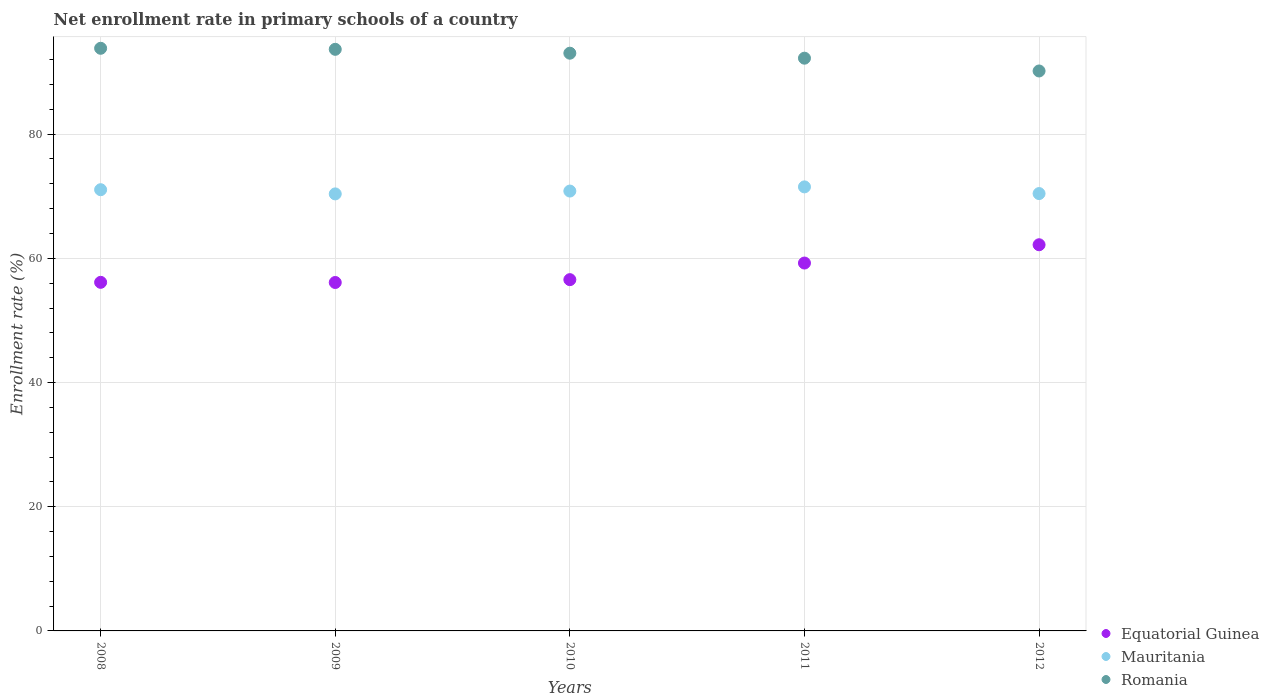How many different coloured dotlines are there?
Provide a short and direct response. 3. Is the number of dotlines equal to the number of legend labels?
Offer a terse response. Yes. What is the enrollment rate in primary schools in Mauritania in 2009?
Your response must be concise. 70.38. Across all years, what is the maximum enrollment rate in primary schools in Romania?
Ensure brevity in your answer.  93.83. Across all years, what is the minimum enrollment rate in primary schools in Mauritania?
Offer a very short reply. 70.38. In which year was the enrollment rate in primary schools in Romania minimum?
Provide a succinct answer. 2012. What is the total enrollment rate in primary schools in Mauritania in the graph?
Your answer should be compact. 354.21. What is the difference between the enrollment rate in primary schools in Mauritania in 2010 and that in 2012?
Ensure brevity in your answer.  0.4. What is the difference between the enrollment rate in primary schools in Equatorial Guinea in 2008 and the enrollment rate in primary schools in Romania in 2012?
Offer a very short reply. -34.04. What is the average enrollment rate in primary schools in Romania per year?
Offer a very short reply. 92.59. In the year 2012, what is the difference between the enrollment rate in primary schools in Mauritania and enrollment rate in primary schools in Romania?
Give a very brief answer. -19.74. What is the ratio of the enrollment rate in primary schools in Romania in 2009 to that in 2012?
Your answer should be very brief. 1.04. What is the difference between the highest and the second highest enrollment rate in primary schools in Romania?
Give a very brief answer. 0.17. What is the difference between the highest and the lowest enrollment rate in primary schools in Equatorial Guinea?
Keep it short and to the point. 6.08. Is the sum of the enrollment rate in primary schools in Mauritania in 2008 and 2010 greater than the maximum enrollment rate in primary schools in Equatorial Guinea across all years?
Offer a very short reply. Yes. How many dotlines are there?
Provide a succinct answer. 3. Does the graph contain grids?
Provide a succinct answer. Yes. What is the title of the graph?
Provide a short and direct response. Net enrollment rate in primary schools of a country. What is the label or title of the Y-axis?
Provide a short and direct response. Enrollment rate (%). What is the Enrollment rate (%) in Equatorial Guinea in 2008?
Provide a short and direct response. 56.14. What is the Enrollment rate (%) in Mauritania in 2008?
Make the answer very short. 71.05. What is the Enrollment rate (%) in Romania in 2008?
Offer a very short reply. 93.83. What is the Enrollment rate (%) of Equatorial Guinea in 2009?
Offer a very short reply. 56.11. What is the Enrollment rate (%) in Mauritania in 2009?
Offer a terse response. 70.38. What is the Enrollment rate (%) of Romania in 2009?
Keep it short and to the point. 93.66. What is the Enrollment rate (%) of Equatorial Guinea in 2010?
Give a very brief answer. 56.57. What is the Enrollment rate (%) of Mauritania in 2010?
Provide a short and direct response. 70.84. What is the Enrollment rate (%) of Romania in 2010?
Your answer should be compact. 93.04. What is the Enrollment rate (%) in Equatorial Guinea in 2011?
Offer a very short reply. 59.24. What is the Enrollment rate (%) in Mauritania in 2011?
Your answer should be very brief. 71.51. What is the Enrollment rate (%) in Romania in 2011?
Your answer should be compact. 92.23. What is the Enrollment rate (%) in Equatorial Guinea in 2012?
Make the answer very short. 62.19. What is the Enrollment rate (%) of Mauritania in 2012?
Your answer should be compact. 70.43. What is the Enrollment rate (%) in Romania in 2012?
Your answer should be compact. 90.17. Across all years, what is the maximum Enrollment rate (%) in Equatorial Guinea?
Offer a very short reply. 62.19. Across all years, what is the maximum Enrollment rate (%) of Mauritania?
Offer a very short reply. 71.51. Across all years, what is the maximum Enrollment rate (%) of Romania?
Provide a succinct answer. 93.83. Across all years, what is the minimum Enrollment rate (%) in Equatorial Guinea?
Offer a terse response. 56.11. Across all years, what is the minimum Enrollment rate (%) of Mauritania?
Your response must be concise. 70.38. Across all years, what is the minimum Enrollment rate (%) of Romania?
Offer a terse response. 90.17. What is the total Enrollment rate (%) in Equatorial Guinea in the graph?
Your response must be concise. 290.25. What is the total Enrollment rate (%) in Mauritania in the graph?
Your answer should be very brief. 354.21. What is the total Enrollment rate (%) of Romania in the graph?
Ensure brevity in your answer.  462.94. What is the difference between the Enrollment rate (%) in Equatorial Guinea in 2008 and that in 2009?
Ensure brevity in your answer.  0.03. What is the difference between the Enrollment rate (%) in Mauritania in 2008 and that in 2009?
Your answer should be very brief. 0.67. What is the difference between the Enrollment rate (%) of Romania in 2008 and that in 2009?
Ensure brevity in your answer.  0.17. What is the difference between the Enrollment rate (%) in Equatorial Guinea in 2008 and that in 2010?
Offer a terse response. -0.43. What is the difference between the Enrollment rate (%) of Mauritania in 2008 and that in 2010?
Provide a short and direct response. 0.22. What is the difference between the Enrollment rate (%) in Romania in 2008 and that in 2010?
Provide a succinct answer. 0.79. What is the difference between the Enrollment rate (%) of Equatorial Guinea in 2008 and that in 2011?
Give a very brief answer. -3.11. What is the difference between the Enrollment rate (%) in Mauritania in 2008 and that in 2011?
Your answer should be very brief. -0.46. What is the difference between the Enrollment rate (%) of Romania in 2008 and that in 2011?
Your response must be concise. 1.59. What is the difference between the Enrollment rate (%) of Equatorial Guinea in 2008 and that in 2012?
Provide a short and direct response. -6.05. What is the difference between the Enrollment rate (%) of Mauritania in 2008 and that in 2012?
Ensure brevity in your answer.  0.62. What is the difference between the Enrollment rate (%) in Romania in 2008 and that in 2012?
Make the answer very short. 3.65. What is the difference between the Enrollment rate (%) of Equatorial Guinea in 2009 and that in 2010?
Ensure brevity in your answer.  -0.46. What is the difference between the Enrollment rate (%) in Mauritania in 2009 and that in 2010?
Give a very brief answer. -0.46. What is the difference between the Enrollment rate (%) of Romania in 2009 and that in 2010?
Keep it short and to the point. 0.62. What is the difference between the Enrollment rate (%) in Equatorial Guinea in 2009 and that in 2011?
Provide a succinct answer. -3.13. What is the difference between the Enrollment rate (%) of Mauritania in 2009 and that in 2011?
Ensure brevity in your answer.  -1.13. What is the difference between the Enrollment rate (%) of Romania in 2009 and that in 2011?
Keep it short and to the point. 1.43. What is the difference between the Enrollment rate (%) of Equatorial Guinea in 2009 and that in 2012?
Offer a terse response. -6.08. What is the difference between the Enrollment rate (%) of Mauritania in 2009 and that in 2012?
Make the answer very short. -0.05. What is the difference between the Enrollment rate (%) of Romania in 2009 and that in 2012?
Provide a succinct answer. 3.49. What is the difference between the Enrollment rate (%) in Equatorial Guinea in 2010 and that in 2011?
Your answer should be compact. -2.67. What is the difference between the Enrollment rate (%) in Mauritania in 2010 and that in 2011?
Offer a terse response. -0.67. What is the difference between the Enrollment rate (%) in Romania in 2010 and that in 2011?
Your response must be concise. 0.8. What is the difference between the Enrollment rate (%) in Equatorial Guinea in 2010 and that in 2012?
Your answer should be compact. -5.62. What is the difference between the Enrollment rate (%) in Mauritania in 2010 and that in 2012?
Provide a succinct answer. 0.4. What is the difference between the Enrollment rate (%) of Romania in 2010 and that in 2012?
Provide a succinct answer. 2.86. What is the difference between the Enrollment rate (%) in Equatorial Guinea in 2011 and that in 2012?
Keep it short and to the point. -2.95. What is the difference between the Enrollment rate (%) of Mauritania in 2011 and that in 2012?
Offer a very short reply. 1.08. What is the difference between the Enrollment rate (%) of Romania in 2011 and that in 2012?
Keep it short and to the point. 2.06. What is the difference between the Enrollment rate (%) in Equatorial Guinea in 2008 and the Enrollment rate (%) in Mauritania in 2009?
Ensure brevity in your answer.  -14.24. What is the difference between the Enrollment rate (%) in Equatorial Guinea in 2008 and the Enrollment rate (%) in Romania in 2009?
Give a very brief answer. -37.52. What is the difference between the Enrollment rate (%) of Mauritania in 2008 and the Enrollment rate (%) of Romania in 2009?
Offer a very short reply. -22.61. What is the difference between the Enrollment rate (%) in Equatorial Guinea in 2008 and the Enrollment rate (%) in Mauritania in 2010?
Your response must be concise. -14.7. What is the difference between the Enrollment rate (%) in Equatorial Guinea in 2008 and the Enrollment rate (%) in Romania in 2010?
Keep it short and to the point. -36.9. What is the difference between the Enrollment rate (%) in Mauritania in 2008 and the Enrollment rate (%) in Romania in 2010?
Ensure brevity in your answer.  -21.98. What is the difference between the Enrollment rate (%) in Equatorial Guinea in 2008 and the Enrollment rate (%) in Mauritania in 2011?
Offer a very short reply. -15.37. What is the difference between the Enrollment rate (%) in Equatorial Guinea in 2008 and the Enrollment rate (%) in Romania in 2011?
Your response must be concise. -36.1. What is the difference between the Enrollment rate (%) in Mauritania in 2008 and the Enrollment rate (%) in Romania in 2011?
Offer a terse response. -21.18. What is the difference between the Enrollment rate (%) of Equatorial Guinea in 2008 and the Enrollment rate (%) of Mauritania in 2012?
Your answer should be compact. -14.29. What is the difference between the Enrollment rate (%) in Equatorial Guinea in 2008 and the Enrollment rate (%) in Romania in 2012?
Keep it short and to the point. -34.04. What is the difference between the Enrollment rate (%) in Mauritania in 2008 and the Enrollment rate (%) in Romania in 2012?
Ensure brevity in your answer.  -19.12. What is the difference between the Enrollment rate (%) of Equatorial Guinea in 2009 and the Enrollment rate (%) of Mauritania in 2010?
Your answer should be compact. -14.72. What is the difference between the Enrollment rate (%) of Equatorial Guinea in 2009 and the Enrollment rate (%) of Romania in 2010?
Keep it short and to the point. -36.93. What is the difference between the Enrollment rate (%) in Mauritania in 2009 and the Enrollment rate (%) in Romania in 2010?
Provide a short and direct response. -22.66. What is the difference between the Enrollment rate (%) of Equatorial Guinea in 2009 and the Enrollment rate (%) of Mauritania in 2011?
Ensure brevity in your answer.  -15.4. What is the difference between the Enrollment rate (%) in Equatorial Guinea in 2009 and the Enrollment rate (%) in Romania in 2011?
Your answer should be compact. -36.12. What is the difference between the Enrollment rate (%) in Mauritania in 2009 and the Enrollment rate (%) in Romania in 2011?
Give a very brief answer. -21.86. What is the difference between the Enrollment rate (%) in Equatorial Guinea in 2009 and the Enrollment rate (%) in Mauritania in 2012?
Your answer should be compact. -14.32. What is the difference between the Enrollment rate (%) in Equatorial Guinea in 2009 and the Enrollment rate (%) in Romania in 2012?
Give a very brief answer. -34.06. What is the difference between the Enrollment rate (%) in Mauritania in 2009 and the Enrollment rate (%) in Romania in 2012?
Offer a terse response. -19.8. What is the difference between the Enrollment rate (%) of Equatorial Guinea in 2010 and the Enrollment rate (%) of Mauritania in 2011?
Provide a short and direct response. -14.94. What is the difference between the Enrollment rate (%) in Equatorial Guinea in 2010 and the Enrollment rate (%) in Romania in 2011?
Offer a very short reply. -35.66. What is the difference between the Enrollment rate (%) of Mauritania in 2010 and the Enrollment rate (%) of Romania in 2011?
Give a very brief answer. -21.4. What is the difference between the Enrollment rate (%) in Equatorial Guinea in 2010 and the Enrollment rate (%) in Mauritania in 2012?
Offer a terse response. -13.86. What is the difference between the Enrollment rate (%) of Equatorial Guinea in 2010 and the Enrollment rate (%) of Romania in 2012?
Offer a terse response. -33.61. What is the difference between the Enrollment rate (%) of Mauritania in 2010 and the Enrollment rate (%) of Romania in 2012?
Offer a very short reply. -19.34. What is the difference between the Enrollment rate (%) of Equatorial Guinea in 2011 and the Enrollment rate (%) of Mauritania in 2012?
Provide a short and direct response. -11.19. What is the difference between the Enrollment rate (%) in Equatorial Guinea in 2011 and the Enrollment rate (%) in Romania in 2012?
Your response must be concise. -30.93. What is the difference between the Enrollment rate (%) in Mauritania in 2011 and the Enrollment rate (%) in Romania in 2012?
Your answer should be very brief. -18.67. What is the average Enrollment rate (%) in Equatorial Guinea per year?
Provide a short and direct response. 58.05. What is the average Enrollment rate (%) in Mauritania per year?
Your answer should be compact. 70.84. What is the average Enrollment rate (%) in Romania per year?
Provide a succinct answer. 92.59. In the year 2008, what is the difference between the Enrollment rate (%) of Equatorial Guinea and Enrollment rate (%) of Mauritania?
Your response must be concise. -14.92. In the year 2008, what is the difference between the Enrollment rate (%) of Equatorial Guinea and Enrollment rate (%) of Romania?
Your answer should be very brief. -37.69. In the year 2008, what is the difference between the Enrollment rate (%) of Mauritania and Enrollment rate (%) of Romania?
Offer a terse response. -22.77. In the year 2009, what is the difference between the Enrollment rate (%) in Equatorial Guinea and Enrollment rate (%) in Mauritania?
Offer a very short reply. -14.27. In the year 2009, what is the difference between the Enrollment rate (%) in Equatorial Guinea and Enrollment rate (%) in Romania?
Offer a very short reply. -37.55. In the year 2009, what is the difference between the Enrollment rate (%) of Mauritania and Enrollment rate (%) of Romania?
Offer a very short reply. -23.28. In the year 2010, what is the difference between the Enrollment rate (%) in Equatorial Guinea and Enrollment rate (%) in Mauritania?
Make the answer very short. -14.27. In the year 2010, what is the difference between the Enrollment rate (%) of Equatorial Guinea and Enrollment rate (%) of Romania?
Make the answer very short. -36.47. In the year 2010, what is the difference between the Enrollment rate (%) of Mauritania and Enrollment rate (%) of Romania?
Give a very brief answer. -22.2. In the year 2011, what is the difference between the Enrollment rate (%) in Equatorial Guinea and Enrollment rate (%) in Mauritania?
Make the answer very short. -12.27. In the year 2011, what is the difference between the Enrollment rate (%) in Equatorial Guinea and Enrollment rate (%) in Romania?
Give a very brief answer. -32.99. In the year 2011, what is the difference between the Enrollment rate (%) in Mauritania and Enrollment rate (%) in Romania?
Your answer should be compact. -20.72. In the year 2012, what is the difference between the Enrollment rate (%) in Equatorial Guinea and Enrollment rate (%) in Mauritania?
Your answer should be compact. -8.24. In the year 2012, what is the difference between the Enrollment rate (%) in Equatorial Guinea and Enrollment rate (%) in Romania?
Provide a succinct answer. -27.99. In the year 2012, what is the difference between the Enrollment rate (%) in Mauritania and Enrollment rate (%) in Romania?
Keep it short and to the point. -19.74. What is the ratio of the Enrollment rate (%) in Equatorial Guinea in 2008 to that in 2009?
Ensure brevity in your answer.  1. What is the ratio of the Enrollment rate (%) in Mauritania in 2008 to that in 2009?
Your answer should be very brief. 1.01. What is the ratio of the Enrollment rate (%) in Equatorial Guinea in 2008 to that in 2010?
Your answer should be very brief. 0.99. What is the ratio of the Enrollment rate (%) in Romania in 2008 to that in 2010?
Provide a short and direct response. 1.01. What is the ratio of the Enrollment rate (%) in Equatorial Guinea in 2008 to that in 2011?
Provide a short and direct response. 0.95. What is the ratio of the Enrollment rate (%) in Mauritania in 2008 to that in 2011?
Your response must be concise. 0.99. What is the ratio of the Enrollment rate (%) in Romania in 2008 to that in 2011?
Your answer should be very brief. 1.02. What is the ratio of the Enrollment rate (%) of Equatorial Guinea in 2008 to that in 2012?
Your answer should be compact. 0.9. What is the ratio of the Enrollment rate (%) in Mauritania in 2008 to that in 2012?
Give a very brief answer. 1.01. What is the ratio of the Enrollment rate (%) in Romania in 2008 to that in 2012?
Make the answer very short. 1.04. What is the ratio of the Enrollment rate (%) in Equatorial Guinea in 2009 to that in 2010?
Your answer should be compact. 0.99. What is the ratio of the Enrollment rate (%) of Romania in 2009 to that in 2010?
Offer a terse response. 1.01. What is the ratio of the Enrollment rate (%) of Equatorial Guinea in 2009 to that in 2011?
Ensure brevity in your answer.  0.95. What is the ratio of the Enrollment rate (%) in Mauritania in 2009 to that in 2011?
Provide a succinct answer. 0.98. What is the ratio of the Enrollment rate (%) of Romania in 2009 to that in 2011?
Your response must be concise. 1.02. What is the ratio of the Enrollment rate (%) in Equatorial Guinea in 2009 to that in 2012?
Ensure brevity in your answer.  0.9. What is the ratio of the Enrollment rate (%) of Mauritania in 2009 to that in 2012?
Give a very brief answer. 1. What is the ratio of the Enrollment rate (%) in Romania in 2009 to that in 2012?
Provide a succinct answer. 1.04. What is the ratio of the Enrollment rate (%) in Equatorial Guinea in 2010 to that in 2011?
Keep it short and to the point. 0.95. What is the ratio of the Enrollment rate (%) of Mauritania in 2010 to that in 2011?
Make the answer very short. 0.99. What is the ratio of the Enrollment rate (%) in Romania in 2010 to that in 2011?
Provide a succinct answer. 1.01. What is the ratio of the Enrollment rate (%) of Equatorial Guinea in 2010 to that in 2012?
Give a very brief answer. 0.91. What is the ratio of the Enrollment rate (%) in Mauritania in 2010 to that in 2012?
Your answer should be very brief. 1.01. What is the ratio of the Enrollment rate (%) in Romania in 2010 to that in 2012?
Provide a succinct answer. 1.03. What is the ratio of the Enrollment rate (%) in Equatorial Guinea in 2011 to that in 2012?
Your answer should be very brief. 0.95. What is the ratio of the Enrollment rate (%) in Mauritania in 2011 to that in 2012?
Make the answer very short. 1.02. What is the ratio of the Enrollment rate (%) in Romania in 2011 to that in 2012?
Your answer should be compact. 1.02. What is the difference between the highest and the second highest Enrollment rate (%) of Equatorial Guinea?
Provide a short and direct response. 2.95. What is the difference between the highest and the second highest Enrollment rate (%) of Mauritania?
Ensure brevity in your answer.  0.46. What is the difference between the highest and the second highest Enrollment rate (%) of Romania?
Keep it short and to the point. 0.17. What is the difference between the highest and the lowest Enrollment rate (%) of Equatorial Guinea?
Your answer should be very brief. 6.08. What is the difference between the highest and the lowest Enrollment rate (%) in Mauritania?
Your answer should be compact. 1.13. What is the difference between the highest and the lowest Enrollment rate (%) of Romania?
Your response must be concise. 3.65. 